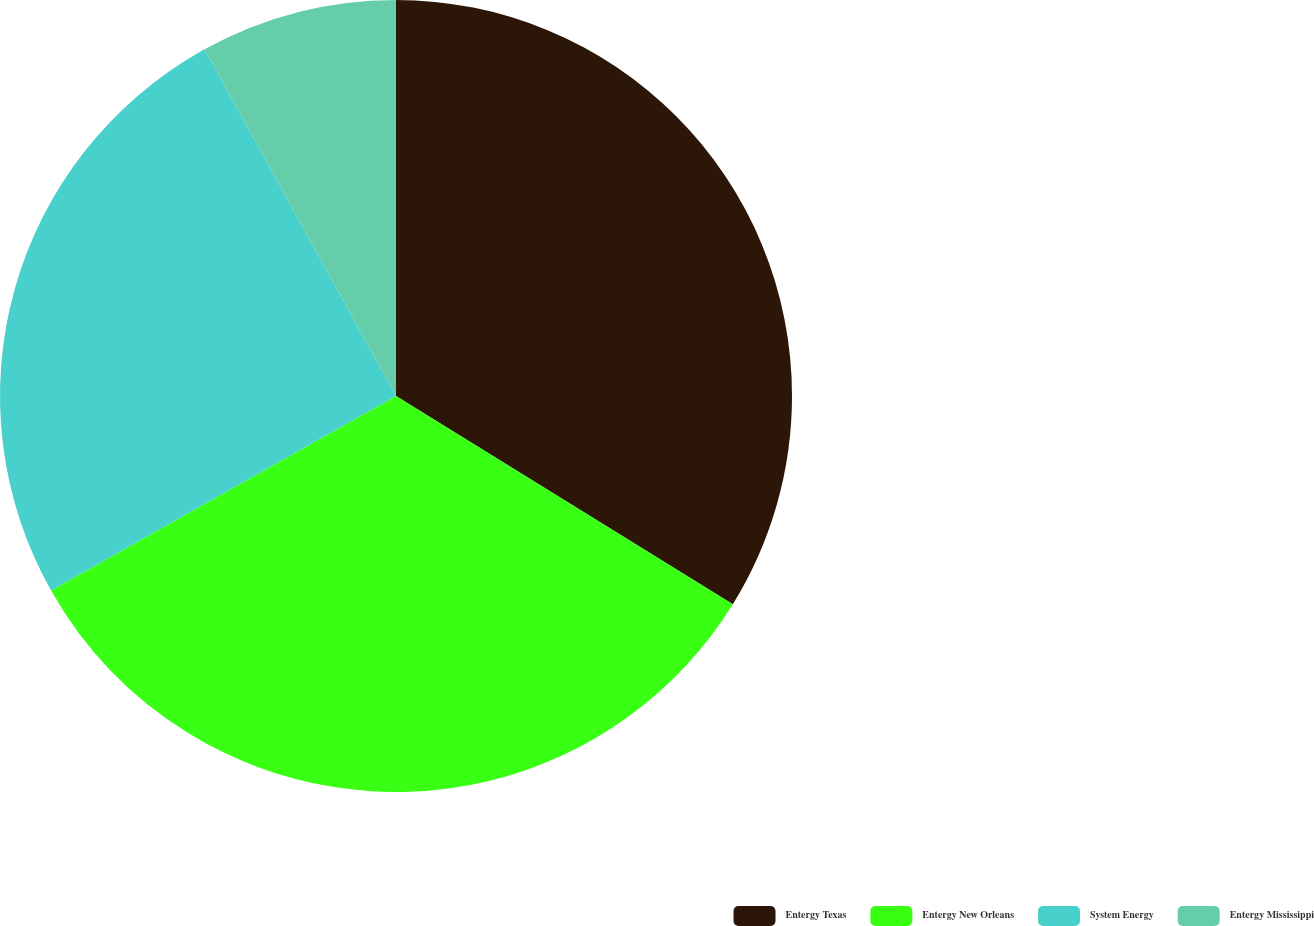Convert chart to OTSL. <chart><loc_0><loc_0><loc_500><loc_500><pie_chart><fcel>Entergy Texas<fcel>Entergy New Orleans<fcel>System Energy<fcel>Entergy Mississippi<nl><fcel>33.81%<fcel>33.01%<fcel>25.14%<fcel>8.03%<nl></chart> 